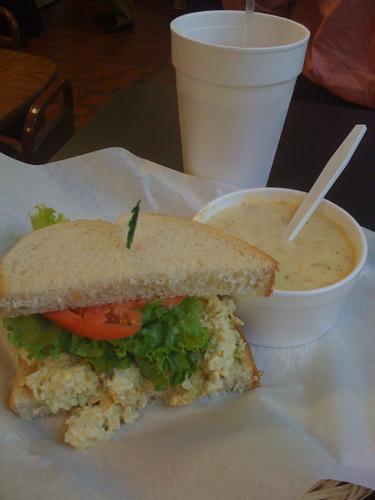How many cups are there?
Give a very brief answer. 2. 